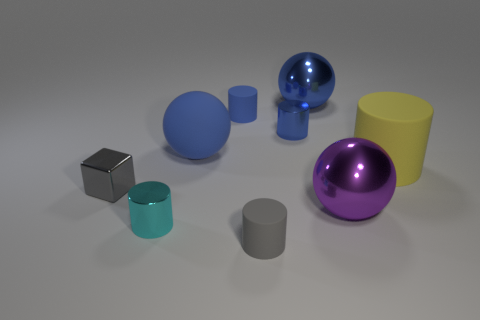Are any tiny purple rubber cubes visible?
Make the answer very short. No. What number of objects are either matte things to the right of the purple metal sphere or large purple shiny objects?
Offer a very short reply. 2. Is the color of the big cylinder the same as the matte cylinder in front of the tiny cyan metal object?
Make the answer very short. No. Is there a blue metallic cylinder that has the same size as the purple metallic object?
Provide a succinct answer. No. The big sphere that is in front of the gray object behind the tiny gray cylinder is made of what material?
Offer a terse response. Metal. What number of tiny matte cylinders are the same color as the block?
Your response must be concise. 1. What is the shape of the purple thing that is the same material as the cube?
Provide a succinct answer. Sphere. There is a metallic cylinder left of the tiny blue matte cylinder; what size is it?
Provide a short and direct response. Small. Is the number of big blue shiny objects behind the tiny blue metallic cylinder the same as the number of large purple things right of the large yellow rubber object?
Your response must be concise. No. What is the color of the tiny matte cylinder that is on the right side of the rubber cylinder to the left of the tiny gray object in front of the small cyan object?
Ensure brevity in your answer.  Gray. 